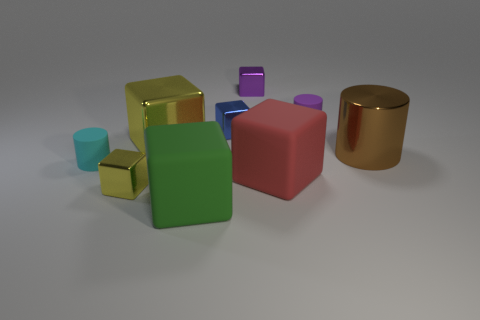Subtract all blue blocks. How many blocks are left? 5 Subtract all cylinders. How many objects are left? 6 Subtract all yellow cubes. How many cubes are left? 4 Subtract 3 cylinders. How many cylinders are left? 0 Subtract all large matte things. Subtract all large yellow cubes. How many objects are left? 6 Add 2 red matte blocks. How many red matte blocks are left? 3 Add 4 small purple metal cubes. How many small purple metal cubes exist? 5 Subtract 0 brown balls. How many objects are left? 9 Subtract all cyan blocks. Subtract all purple cylinders. How many blocks are left? 6 Subtract all gray cubes. How many brown cylinders are left? 1 